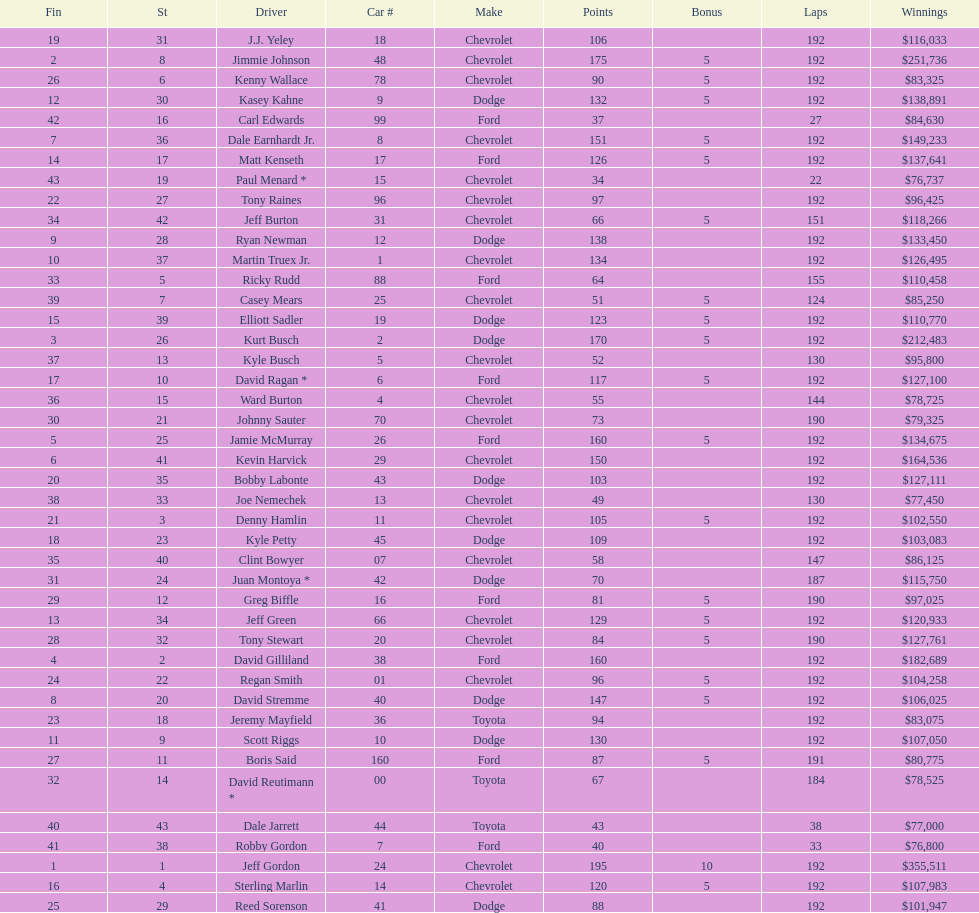Which make had the most consecutive finishes at the aarons 499? Chevrolet. 